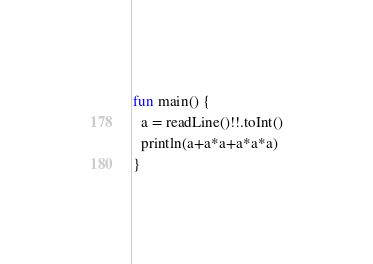<code> <loc_0><loc_0><loc_500><loc_500><_Kotlin_>fun main() {
  a = readLine()!!.toInt()
  println(a+a*a+a*a*a)
}</code> 